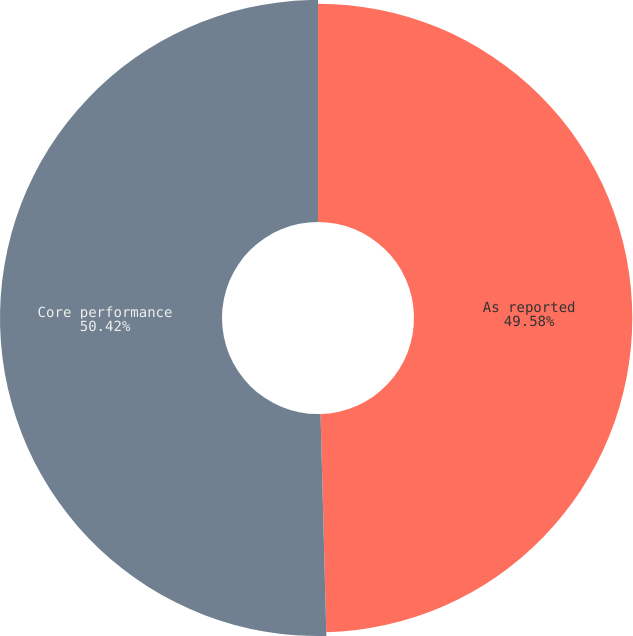Convert chart. <chart><loc_0><loc_0><loc_500><loc_500><pie_chart><fcel>As reported<fcel>Core performance<nl><fcel>49.58%<fcel>50.42%<nl></chart> 